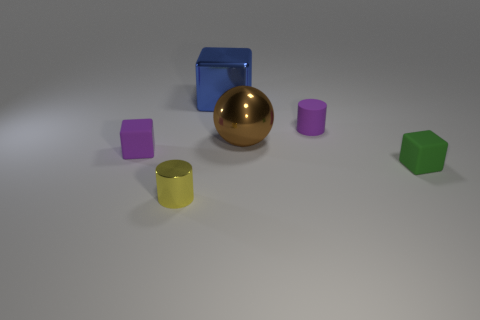Subtract all yellow balls. Subtract all green cubes. How many balls are left? 1 Add 2 yellow cylinders. How many objects exist? 8 Subtract all balls. How many objects are left? 5 Add 4 brown balls. How many brown balls exist? 5 Subtract 0 gray blocks. How many objects are left? 6 Subtract all yellow spheres. Subtract all big blue objects. How many objects are left? 5 Add 6 tiny blocks. How many tiny blocks are left? 8 